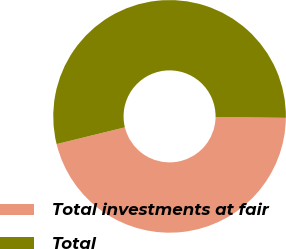Convert chart to OTSL. <chart><loc_0><loc_0><loc_500><loc_500><pie_chart><fcel>Total investments at fair<fcel>Total<nl><fcel>45.97%<fcel>54.03%<nl></chart> 